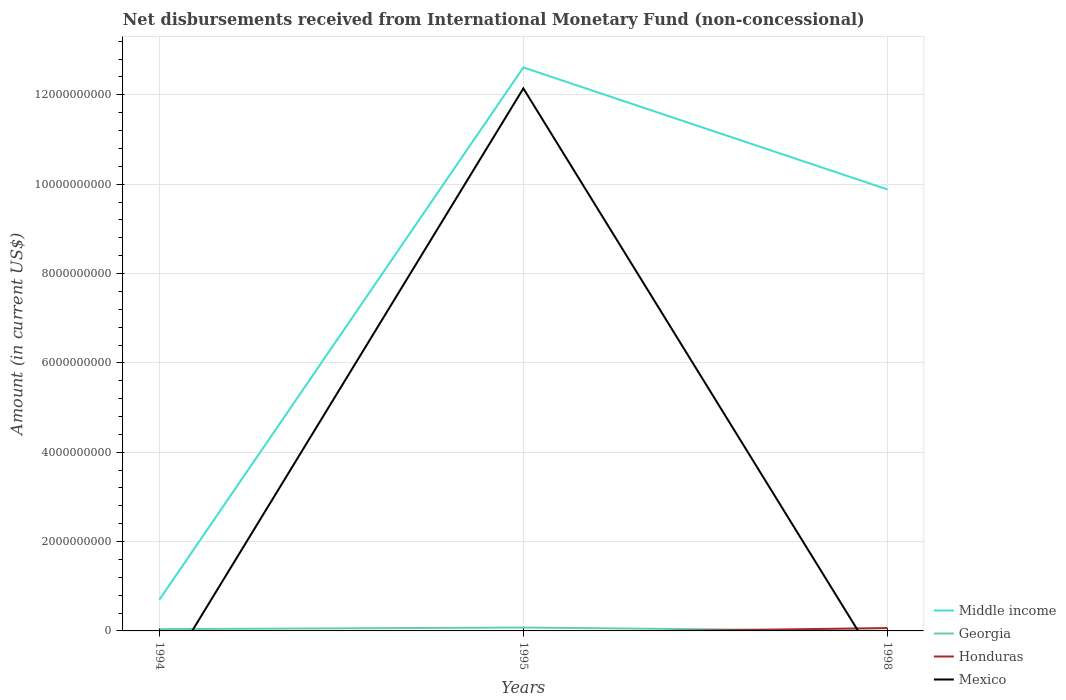Does the line corresponding to Honduras intersect with the line corresponding to Mexico?
Provide a succinct answer. Yes. Is the number of lines equal to the number of legend labels?
Provide a succinct answer. No. Across all years, what is the maximum amount of disbursements received from International Monetary Fund in Honduras?
Make the answer very short. 0. What is the total amount of disbursements received from International Monetary Fund in Middle income in the graph?
Your answer should be compact. -1.19e+1. What is the difference between the highest and the second highest amount of disbursements received from International Monetary Fund in Georgia?
Make the answer very short. 7.58e+07. What is the difference between the highest and the lowest amount of disbursements received from International Monetary Fund in Georgia?
Provide a succinct answer. 2. Is the amount of disbursements received from International Monetary Fund in Mexico strictly greater than the amount of disbursements received from International Monetary Fund in Middle income over the years?
Provide a short and direct response. Yes. How many lines are there?
Your response must be concise. 4. How many years are there in the graph?
Give a very brief answer. 3. What is the difference between two consecutive major ticks on the Y-axis?
Keep it short and to the point. 2.00e+09. Does the graph contain any zero values?
Your answer should be very brief. Yes. Where does the legend appear in the graph?
Your response must be concise. Bottom right. What is the title of the graph?
Your answer should be compact. Net disbursements received from International Monetary Fund (non-concessional). What is the label or title of the X-axis?
Your answer should be compact. Years. What is the label or title of the Y-axis?
Offer a very short reply. Amount (in current US$). What is the Amount (in current US$) of Middle income in 1994?
Offer a very short reply. 6.96e+08. What is the Amount (in current US$) in Georgia in 1994?
Make the answer very short. 3.97e+07. What is the Amount (in current US$) of Mexico in 1994?
Offer a terse response. 0. What is the Amount (in current US$) in Middle income in 1995?
Ensure brevity in your answer.  1.26e+1. What is the Amount (in current US$) of Georgia in 1995?
Provide a succinct answer. 7.58e+07. What is the Amount (in current US$) of Honduras in 1995?
Make the answer very short. 0. What is the Amount (in current US$) of Mexico in 1995?
Provide a short and direct response. 1.21e+1. What is the Amount (in current US$) in Middle income in 1998?
Make the answer very short. 9.88e+09. What is the Amount (in current US$) in Georgia in 1998?
Keep it short and to the point. 0. What is the Amount (in current US$) in Honduras in 1998?
Offer a very short reply. 6.44e+07. What is the Amount (in current US$) of Mexico in 1998?
Give a very brief answer. 0. Across all years, what is the maximum Amount (in current US$) of Middle income?
Your answer should be very brief. 1.26e+1. Across all years, what is the maximum Amount (in current US$) of Georgia?
Provide a short and direct response. 7.58e+07. Across all years, what is the maximum Amount (in current US$) in Honduras?
Give a very brief answer. 6.44e+07. Across all years, what is the maximum Amount (in current US$) in Mexico?
Your answer should be compact. 1.21e+1. Across all years, what is the minimum Amount (in current US$) in Middle income?
Your answer should be compact. 6.96e+08. Across all years, what is the minimum Amount (in current US$) in Georgia?
Offer a very short reply. 0. What is the total Amount (in current US$) in Middle income in the graph?
Ensure brevity in your answer.  2.32e+1. What is the total Amount (in current US$) of Georgia in the graph?
Make the answer very short. 1.16e+08. What is the total Amount (in current US$) in Honduras in the graph?
Provide a succinct answer. 6.44e+07. What is the total Amount (in current US$) of Mexico in the graph?
Offer a terse response. 1.21e+1. What is the difference between the Amount (in current US$) in Middle income in 1994 and that in 1995?
Offer a terse response. -1.19e+1. What is the difference between the Amount (in current US$) of Georgia in 1994 and that in 1995?
Give a very brief answer. -3.60e+07. What is the difference between the Amount (in current US$) in Middle income in 1994 and that in 1998?
Your answer should be very brief. -9.19e+09. What is the difference between the Amount (in current US$) in Middle income in 1995 and that in 1998?
Ensure brevity in your answer.  2.73e+09. What is the difference between the Amount (in current US$) of Middle income in 1994 and the Amount (in current US$) of Georgia in 1995?
Your response must be concise. 6.20e+08. What is the difference between the Amount (in current US$) of Middle income in 1994 and the Amount (in current US$) of Mexico in 1995?
Ensure brevity in your answer.  -1.14e+1. What is the difference between the Amount (in current US$) in Georgia in 1994 and the Amount (in current US$) in Mexico in 1995?
Provide a short and direct response. -1.21e+1. What is the difference between the Amount (in current US$) in Middle income in 1994 and the Amount (in current US$) in Honduras in 1998?
Your response must be concise. 6.31e+08. What is the difference between the Amount (in current US$) in Georgia in 1994 and the Amount (in current US$) in Honduras in 1998?
Offer a terse response. -2.47e+07. What is the difference between the Amount (in current US$) of Middle income in 1995 and the Amount (in current US$) of Honduras in 1998?
Your answer should be compact. 1.25e+1. What is the difference between the Amount (in current US$) in Georgia in 1995 and the Amount (in current US$) in Honduras in 1998?
Offer a very short reply. 1.13e+07. What is the average Amount (in current US$) of Middle income per year?
Give a very brief answer. 7.73e+09. What is the average Amount (in current US$) in Georgia per year?
Offer a very short reply. 3.85e+07. What is the average Amount (in current US$) in Honduras per year?
Provide a succinct answer. 2.15e+07. What is the average Amount (in current US$) of Mexico per year?
Your answer should be compact. 4.05e+09. In the year 1994, what is the difference between the Amount (in current US$) in Middle income and Amount (in current US$) in Georgia?
Offer a terse response. 6.56e+08. In the year 1995, what is the difference between the Amount (in current US$) of Middle income and Amount (in current US$) of Georgia?
Make the answer very short. 1.25e+1. In the year 1995, what is the difference between the Amount (in current US$) of Middle income and Amount (in current US$) of Mexico?
Provide a succinct answer. 4.69e+08. In the year 1995, what is the difference between the Amount (in current US$) of Georgia and Amount (in current US$) of Mexico?
Keep it short and to the point. -1.21e+1. In the year 1998, what is the difference between the Amount (in current US$) in Middle income and Amount (in current US$) in Honduras?
Offer a terse response. 9.82e+09. What is the ratio of the Amount (in current US$) of Middle income in 1994 to that in 1995?
Give a very brief answer. 0.06. What is the ratio of the Amount (in current US$) of Georgia in 1994 to that in 1995?
Make the answer very short. 0.52. What is the ratio of the Amount (in current US$) of Middle income in 1994 to that in 1998?
Provide a short and direct response. 0.07. What is the ratio of the Amount (in current US$) of Middle income in 1995 to that in 1998?
Offer a very short reply. 1.28. What is the difference between the highest and the second highest Amount (in current US$) in Middle income?
Offer a very short reply. 2.73e+09. What is the difference between the highest and the lowest Amount (in current US$) of Middle income?
Provide a succinct answer. 1.19e+1. What is the difference between the highest and the lowest Amount (in current US$) in Georgia?
Offer a terse response. 7.58e+07. What is the difference between the highest and the lowest Amount (in current US$) of Honduras?
Give a very brief answer. 6.44e+07. What is the difference between the highest and the lowest Amount (in current US$) in Mexico?
Your answer should be very brief. 1.21e+1. 